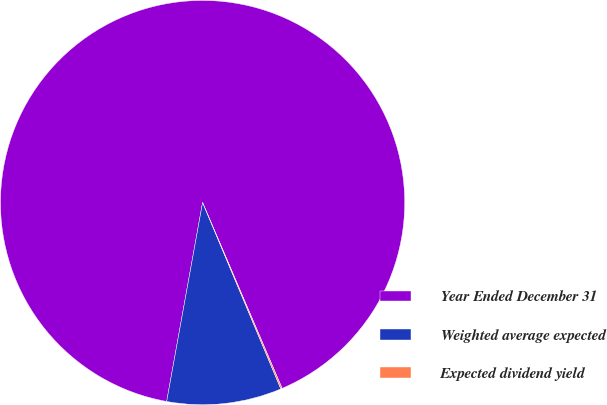Convert chart to OTSL. <chart><loc_0><loc_0><loc_500><loc_500><pie_chart><fcel>Year Ended December 31<fcel>Weighted average expected<fcel>Expected dividend yield<nl><fcel>90.71%<fcel>9.17%<fcel>0.11%<nl></chart> 